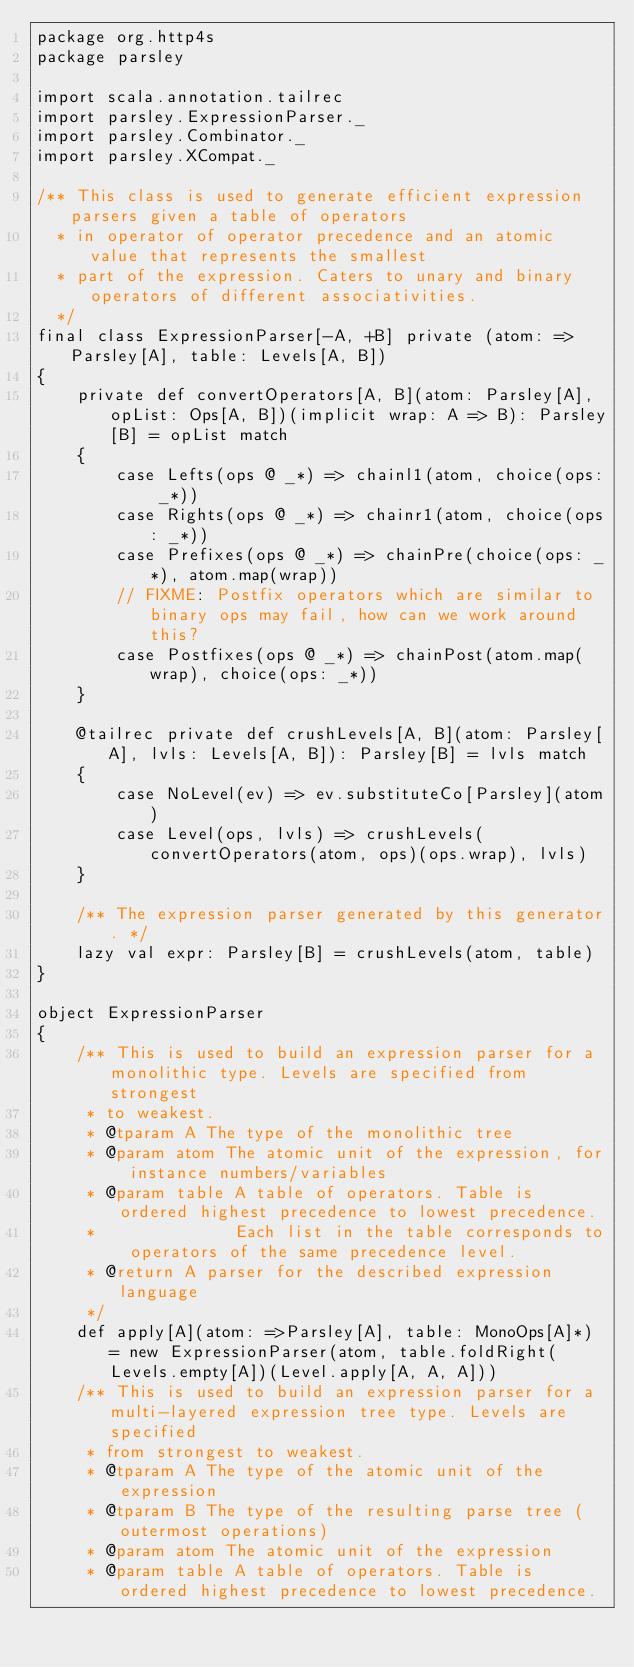<code> <loc_0><loc_0><loc_500><loc_500><_Scala_>package org.http4s
package parsley

import scala.annotation.tailrec
import parsley.ExpressionParser._
import parsley.Combinator._
import parsley.XCompat._

/** This class is used to generate efficient expression parsers given a table of operators
  * in operator of operator precedence and an atomic value that represents the smallest
  * part of the expression. Caters to unary and binary operators of different associativities.
  */
final class ExpressionParser[-A, +B] private (atom: =>Parsley[A], table: Levels[A, B])
{
    private def convertOperators[A, B](atom: Parsley[A], opList: Ops[A, B])(implicit wrap: A => B): Parsley[B] = opList match
    {
        case Lefts(ops @ _*) => chainl1(atom, choice(ops: _*))
        case Rights(ops @ _*) => chainr1(atom, choice(ops: _*))
        case Prefixes(ops @ _*) => chainPre(choice(ops: _*), atom.map(wrap))
        // FIXME: Postfix operators which are similar to binary ops may fail, how can we work around this?
        case Postfixes(ops @ _*) => chainPost(atom.map(wrap), choice(ops: _*))
    }

    @tailrec private def crushLevels[A, B](atom: Parsley[A], lvls: Levels[A, B]): Parsley[B] = lvls match
    {
        case NoLevel(ev) => ev.substituteCo[Parsley](atom)
        case Level(ops, lvls) => crushLevels(convertOperators(atom, ops)(ops.wrap), lvls)
    }

    /** The expression parser generated by this generator. */
    lazy val expr: Parsley[B] = crushLevels(atom, table)
}

object ExpressionParser
{
    /** This is used to build an expression parser for a monolithic type. Levels are specified from strongest
     * to weakest.
     * @tparam A The type of the monolithic tree
     * @param atom The atomic unit of the expression, for instance numbers/variables
     * @param table A table of operators. Table is ordered highest precedence to lowest precedence.
     *              Each list in the table corresponds to operators of the same precedence level.
     * @return A parser for the described expression language
     */
    def apply[A](atom: =>Parsley[A], table: MonoOps[A]*) = new ExpressionParser(atom, table.foldRight(Levels.empty[A])(Level.apply[A, A, A]))
    /** This is used to build an expression parser for a multi-layered expression tree type. Levels are specified
     * from strongest to weakest.
     * @tparam A The type of the atomic unit of the expression
     * @tparam B The type of the resulting parse tree (outermost operations)
     * @param atom The atomic unit of the expression
     * @param table A table of operators. Table is ordered highest precedence to lowest precedence.</code> 